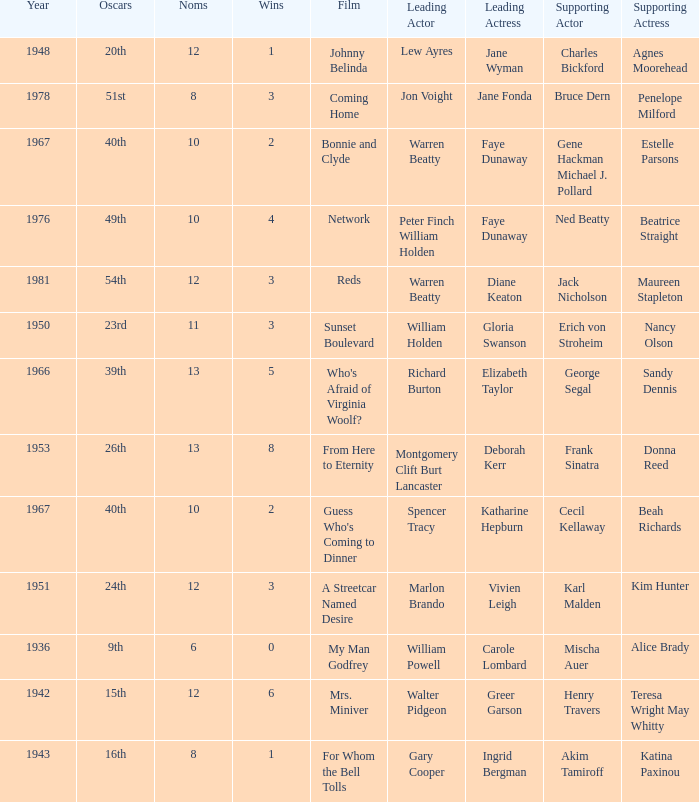In a film where diane keaton was the lead actress, who was the actress in a supporting role? Maureen Stapleton. 